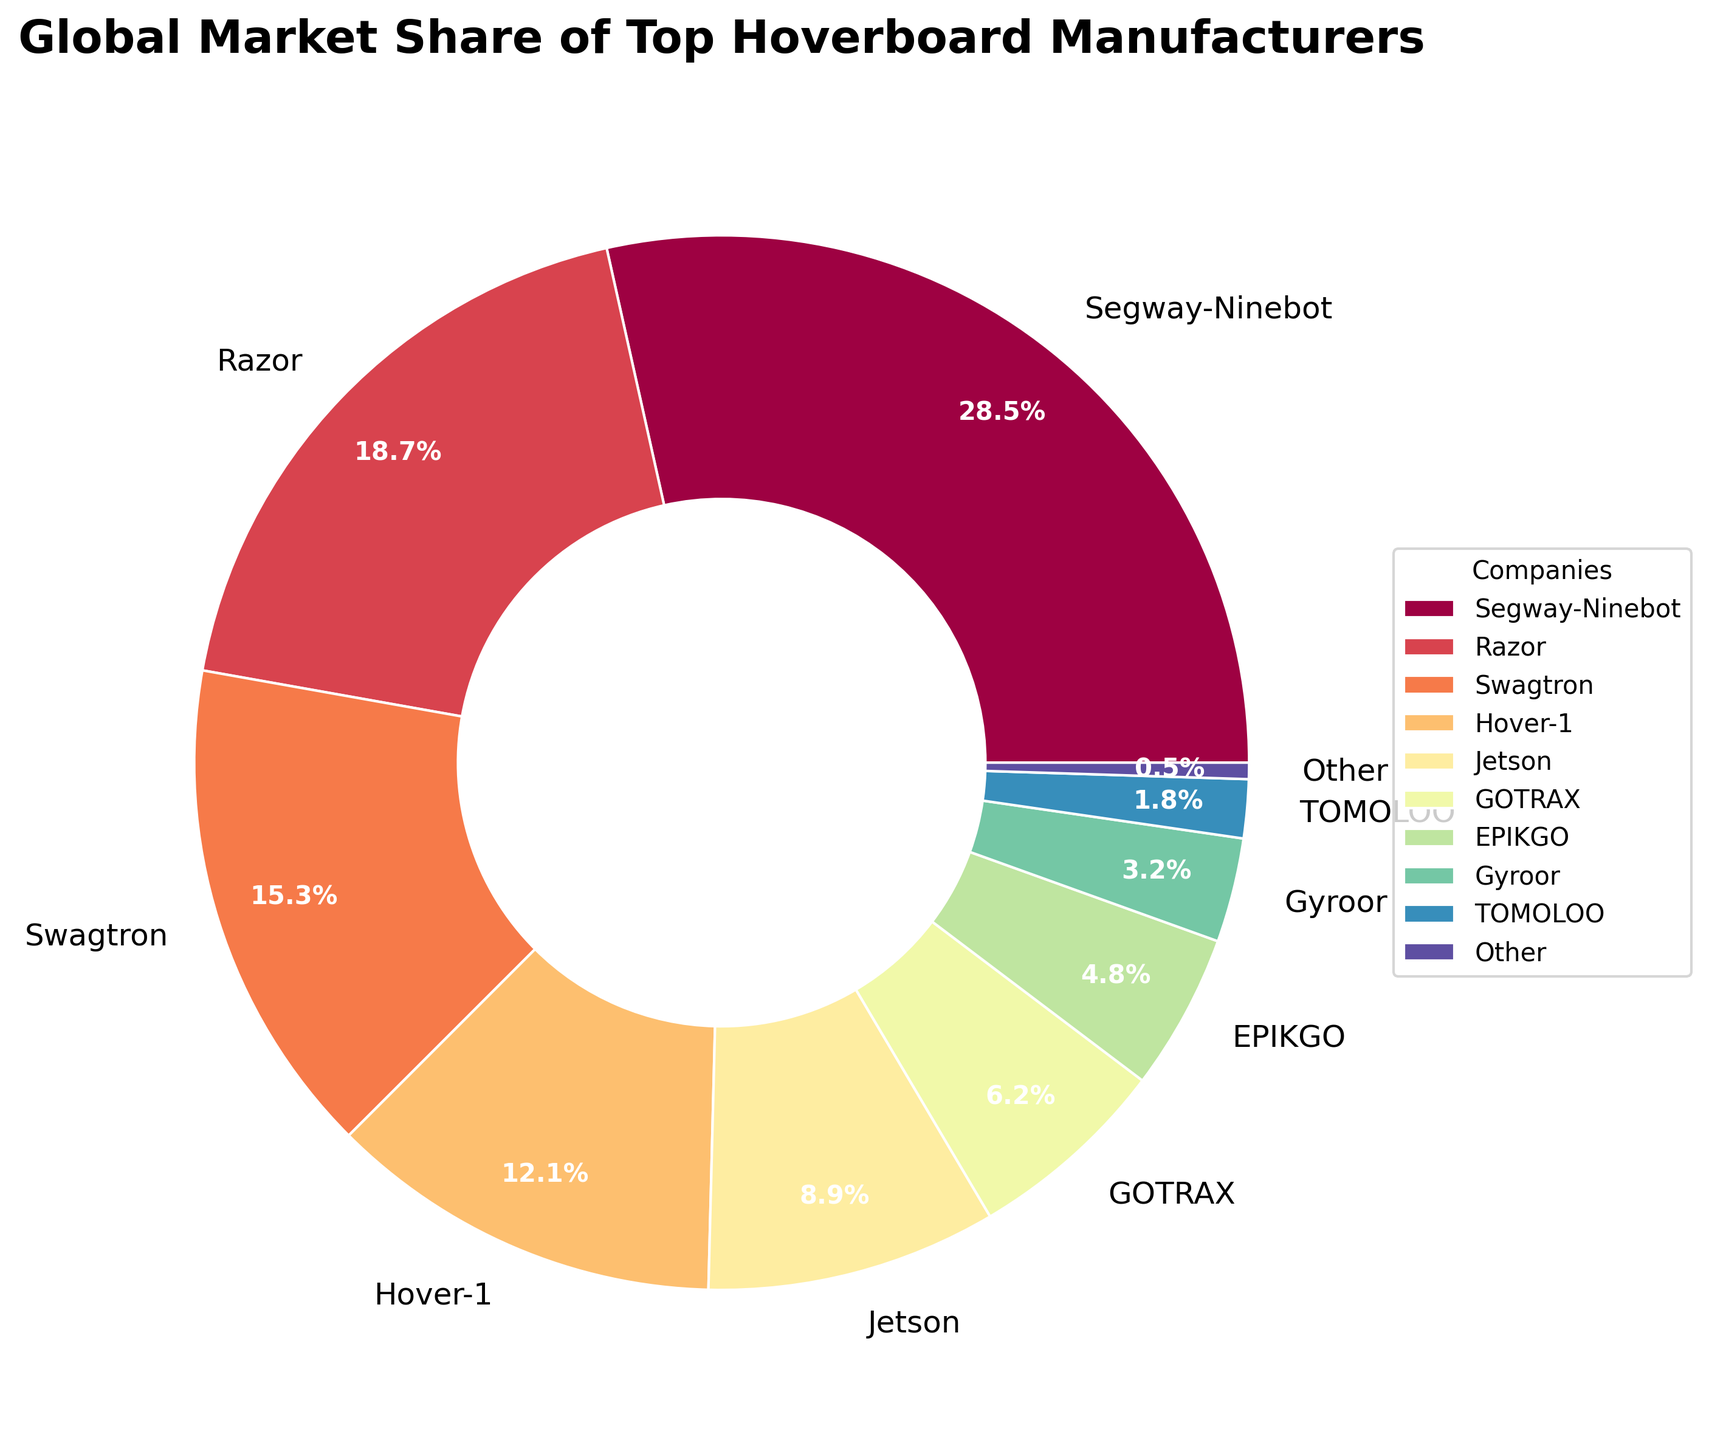What company has the largest market share? The segment with the highest percentage on the pie chart will indicate the company with the largest market share. The label on that segment reads "Segway-Ninebot", which shows 28.5%.
Answer: Segway-Ninebot What is the combined market share of Swagtron and Razor? The market shares of Swagtron and Razor are 15.3% and 18.7%, respectively. Summing these values: 15.3 + 18.7 = 34.0%.
Answer: 34.0% Which company has the smallest market share and what is it? The smallest segment is labeled "Other," which shows a market share of 0.5%.
Answer: Other, 0.5% Is Swagtron's market share greater than Gyroor's and by how much? Swagtron's market share is 15.3%, and Gyroor's is 3.2%. The difference is calculated by subtracting 3.2 from 15.3, which gives 12.1%.
Answer: Yes, by 12.1% What proportion of the market does Hover-1 and Jetson collectively cover? Hover-1's market share is 12.1%, and Jetson's is 8.9%. Adding these values gives 12.1 + 8.9 = 21.0%.
Answer: 21.0% Who has a larger market share, GOTRAX or EPIKGO, and by what margin? GOTRAX holds a 6.2% market share, while EPIKGO has 4.8%. The difference is 6.2 - 4.8 = 1.4%.
Answer: GOTRAX, by 1.4% What is the market share of companies with less than 10% market share? Companies with less than 10% market share are Jetson (8.9%), GOTRAX (6.2%), EPIKGO (4.8%), Gyroor (3.2%), TOMOLOO (1.8%), and Other (0.5%). Summing these: 8.9 + 6.2 + 4.8 + 3.2 + 1.8 + 0.5 = 25.4%.
Answer: 25.4% Which company ranks second in market share? The second largest segment in the pie chart is labeled Razor with a market share of 18.7%.
Answer: Razor If Segway-Ninebot and Swagtron merge, what would be their total market share? Segway-Ninebot's market share is 28.5%, and Swagtron's is 15.3%. Adding these values: 28.5 + 15.3 = 43.8%.
Answer: 43.8% What is the total market share of the top three companies? The top three companies are Segway-Ninebot (28.5%), Razor (18.7%), and Swagtron (15.3%). Their total market share is 28.5 + 18.7 + 15.3 = 62.5%.
Answer: 62.5% 